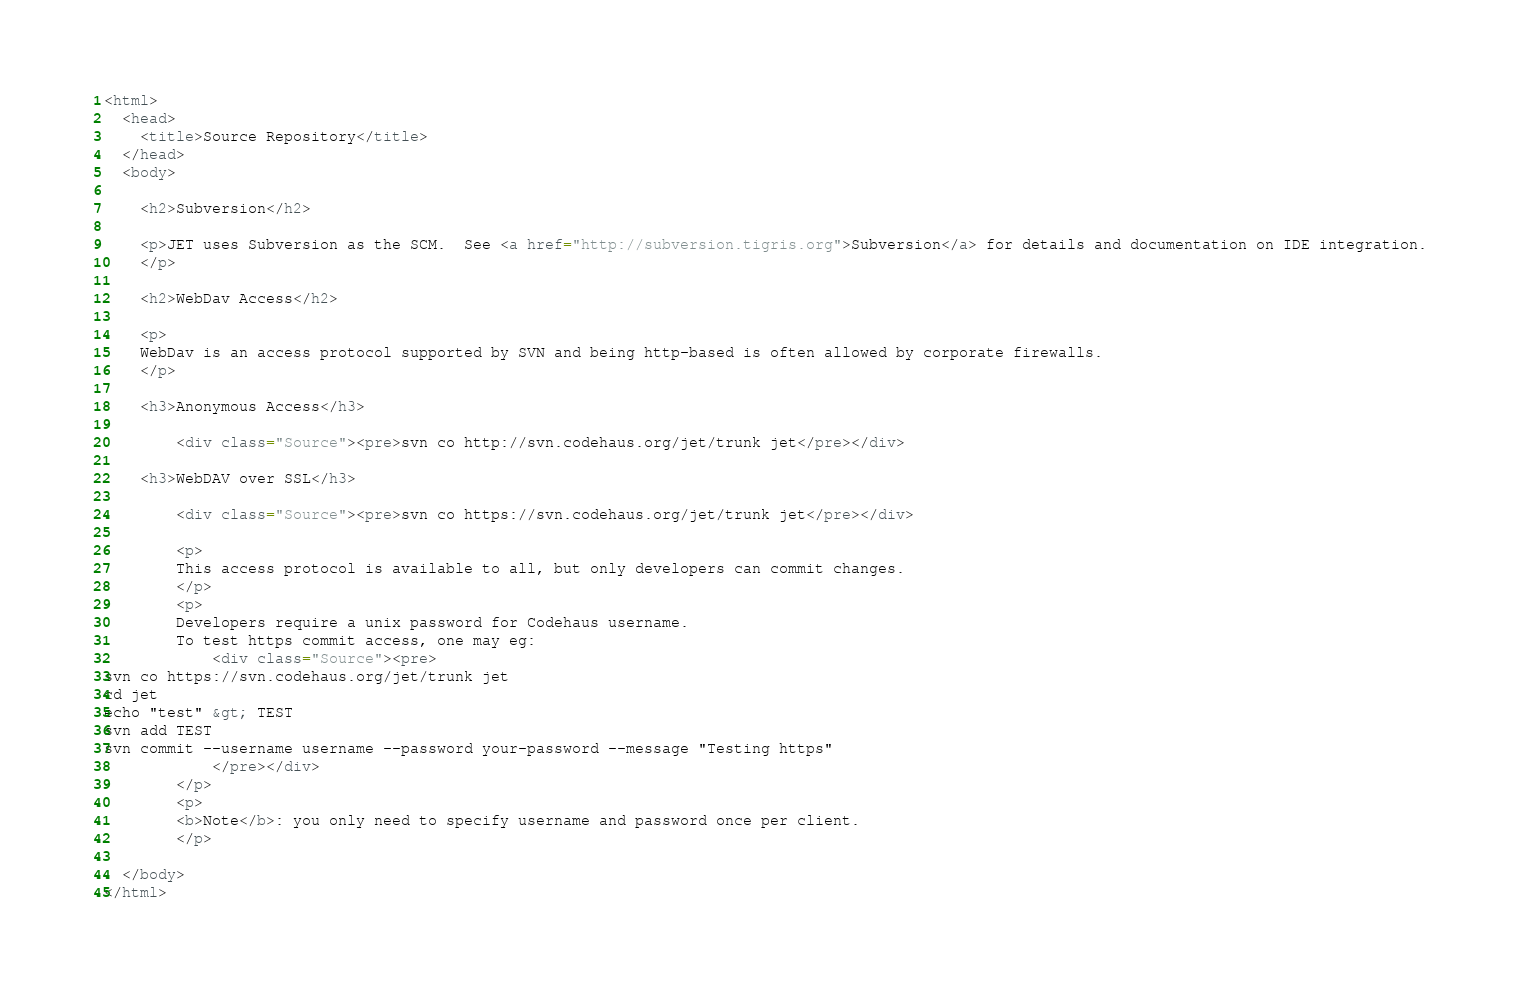Convert code to text. <code><loc_0><loc_0><loc_500><loc_500><_HTML_><html>
  <head>
    <title>Source Repository</title>
  </head>
  <body>

    <h2>Subversion</h2>
    
	<p>JET uses Subversion as the SCM.  See <a href="http://subversion.tigris.org">Subversion</a> for details and documentation on IDE integration.
	</p>

	<h2>WebDav Access</h2>

	<p>
	WebDav is an access protocol supported by SVN and being http-based is often allowed by corporate firewalls. 
	</p>
	
	<h3>Anonymous Access</h3>
			
		<div class="Source"><pre>svn co http://svn.codehaus.org/jet/trunk jet</pre></div>
		
	<h3>WebDAV over SSL</h3>

		<div class="Source"><pre>svn co https://svn.codehaus.org/jet/trunk jet</pre></div>

		<p>
		This access protocol is available to all, but only developers can commit changes.    
		</p>
		<p>
		Developers require a unix password for Codehaus username. 
		To test https commit access, one may eg: 
			<div class="Source"><pre>
svn co https://svn.codehaus.org/jet/trunk jet
cd jet
echo "test" &gt; TEST
svn add TEST
svn commit --username username --password your-password --message "Testing https"
			</pre></div>
		</p>
		<p>
		<b>Note</b>: you only need to specify username and password once per client.
		</p>
	
  </body>
</html>
</code> 